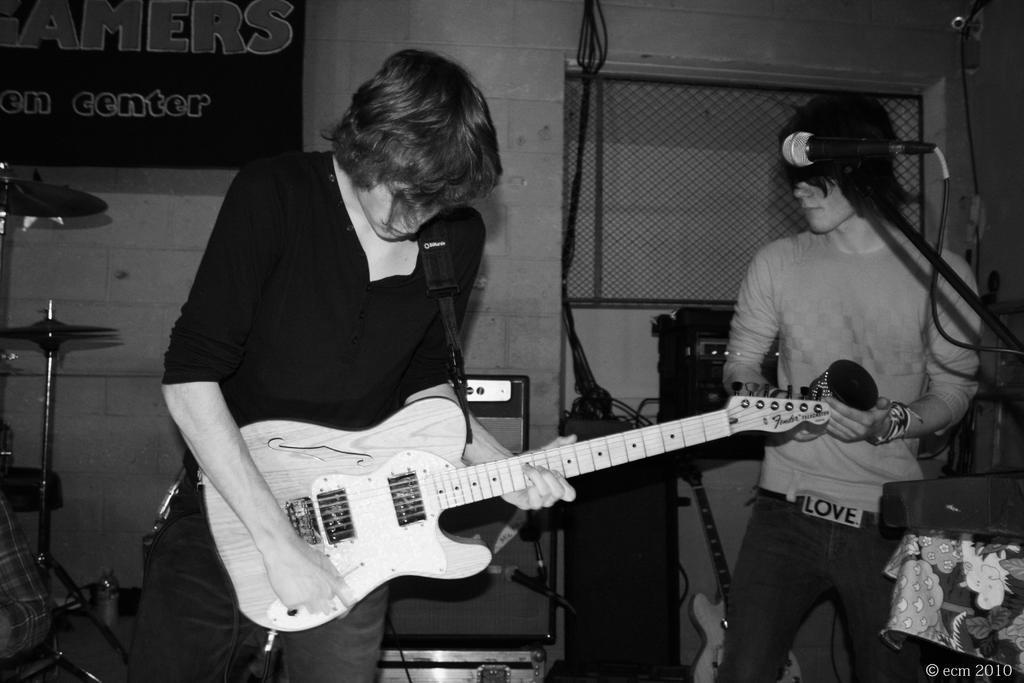How would you summarize this image in a sentence or two? In this image there are two persons who are playing musical instruments. 